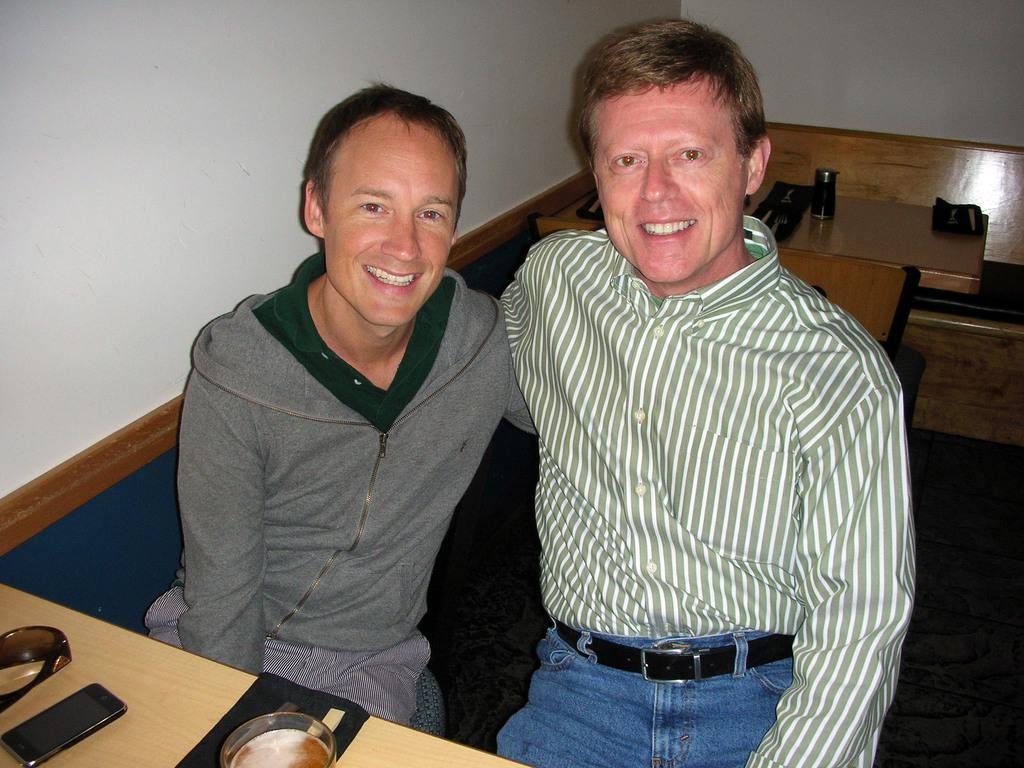In one or two sentences, can you explain what this image depicts? There are two persons sitting and smiling. There are tables, benches. On the table there is a mobile, goggles, and a glass. In the background there is a wall. 